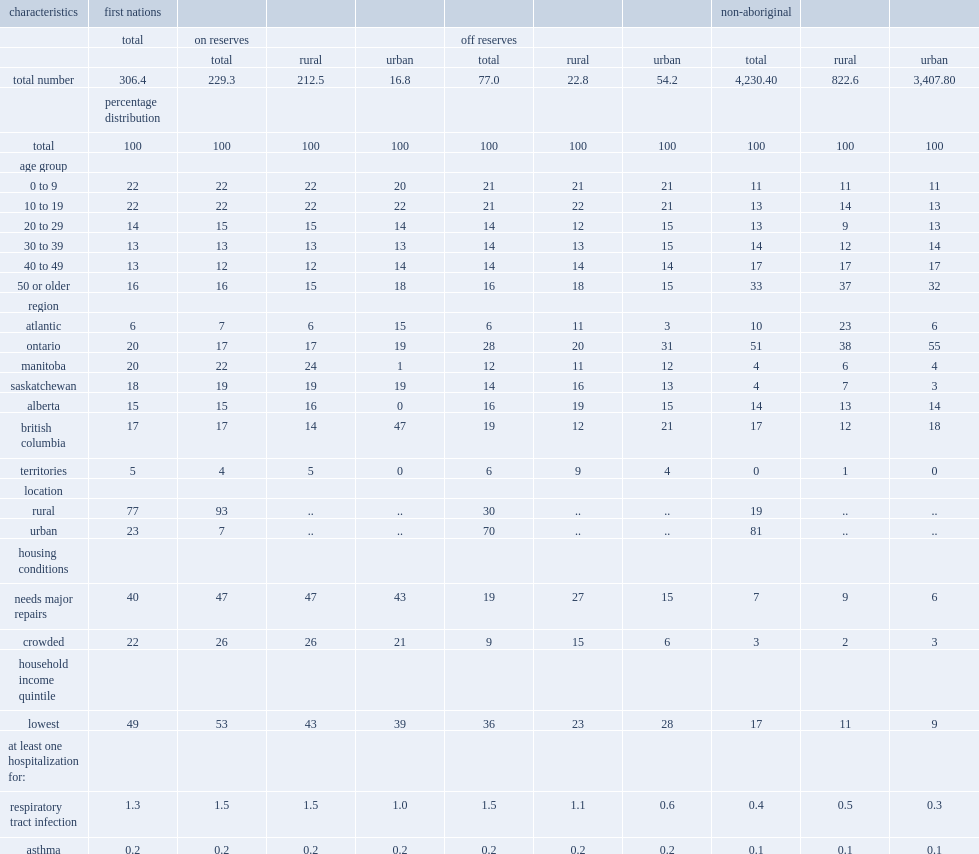What the percent of first nations people in dwellings that needed major repairs? 40.0. What the percent of first nations people lived in crowded conditions? 22.0. What was the percent of non-aboriginal people in dwellings that needed major repairs? 7.0. What was the percent of non-aboriginal people in crowded conditions? 3.0. What was the percent of first nations people in households in the lowest income quintile? 49.0. What was the percent of the non-aboriginal population in households in the lowest income quintile? 17.0. Among those in rural areas, how many times were first nations people living on reserves more likely than non-aboriginal people to be hospitalized for a respiratory tract infection? 3. How many times of the rate for first nations people living on reserves was more than that for non-aboriginal people? 3.333333. How many times were first nations people more likely than non-aboriginal people to be hospitalized for asthma regardless of whether they lived on or off reserves or in rural or urban areas? 2. 